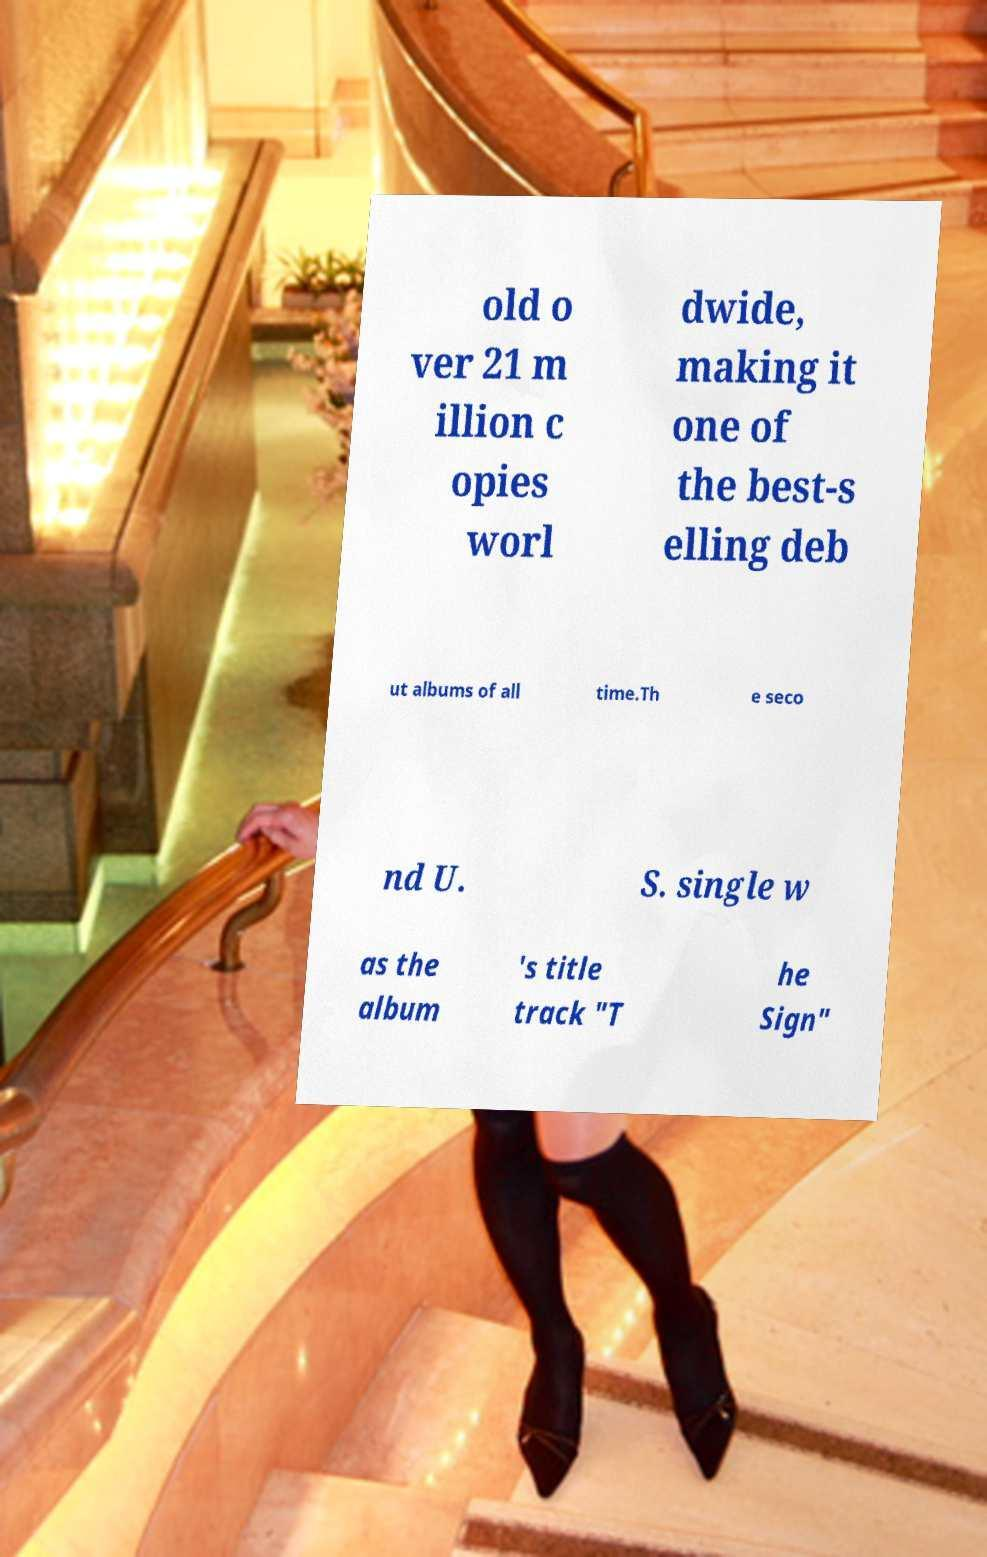There's text embedded in this image that I need extracted. Can you transcribe it verbatim? old o ver 21 m illion c opies worl dwide, making it one of the best-s elling deb ut albums of all time.Th e seco nd U. S. single w as the album 's title track "T he Sign" 